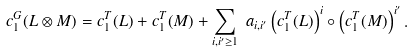<formula> <loc_0><loc_0><loc_500><loc_500>c ^ { G } _ { 1 } ( L \otimes M ) = c ^ { T } _ { 1 } ( L ) + c ^ { T } _ { 1 } ( M ) + { \underset { i , i ^ { \prime } \geq 1 } \sum } \ a _ { i , i ^ { \prime } } \left ( c ^ { T } _ { 1 } ( L ) \right ) ^ { i } \circ \left ( c ^ { T } _ { 1 } ( M ) \right ) ^ { i ^ { \prime } } .</formula> 